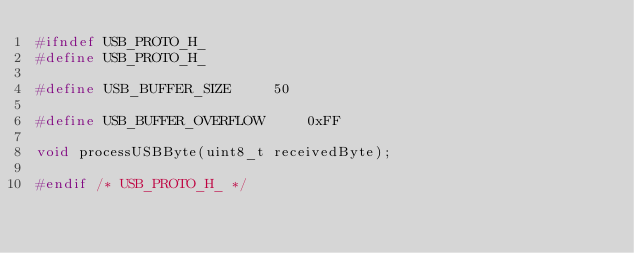Convert code to text. <code><loc_0><loc_0><loc_500><loc_500><_C_>#ifndef USB_PROTO_H_
#define USB_PROTO_H_

#define USB_BUFFER_SIZE		50

#define USB_BUFFER_OVERFLOW		0xFF

void processUSBByte(uint8_t receivedByte);

#endif /* USB_PROTO_H_ */
</code> 